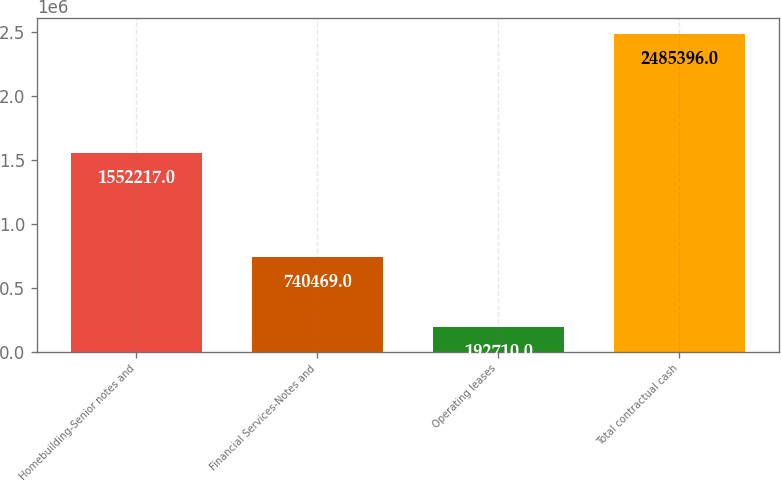Convert chart to OTSL. <chart><loc_0><loc_0><loc_500><loc_500><bar_chart><fcel>Homebuilding-Senior notes and<fcel>Financial Services-Notes and<fcel>Operating leases<fcel>Total contractual cash<nl><fcel>1.55222e+06<fcel>740469<fcel>192710<fcel>2.4854e+06<nl></chart> 